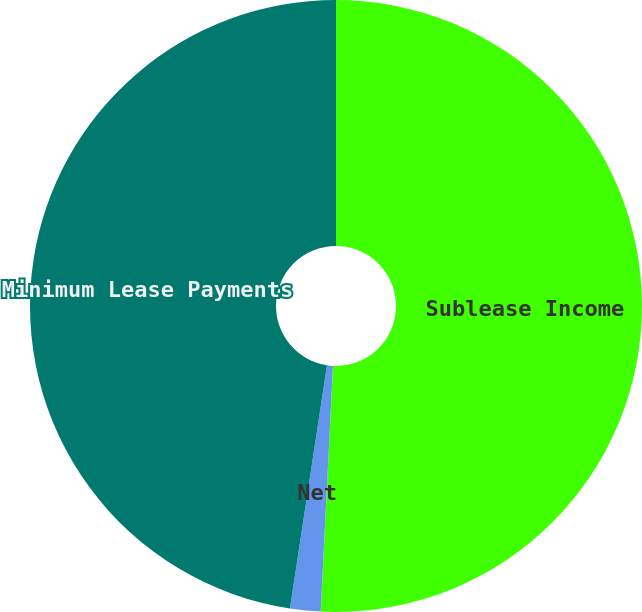<chart> <loc_0><loc_0><loc_500><loc_500><pie_chart><fcel>Sublease Income<fcel>Net<fcel>Minimum Lease Payments<nl><fcel>50.8%<fcel>1.61%<fcel>47.6%<nl></chart> 